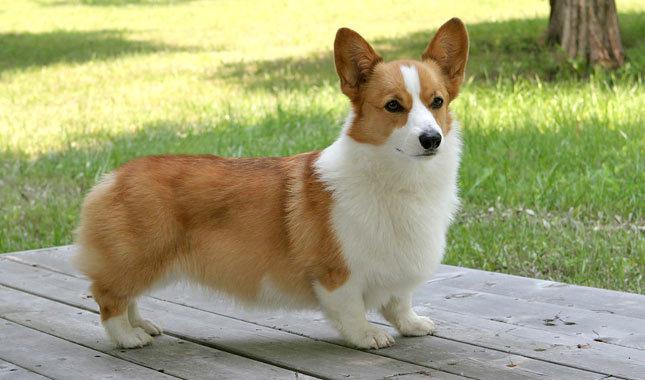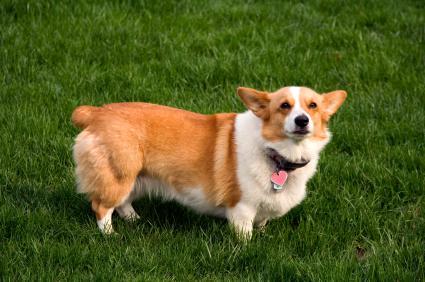The first image is the image on the left, the second image is the image on the right. Evaluate the accuracy of this statement regarding the images: "An image features a multi-colored dog with black markings that create a mask-look.". Is it true? Answer yes or no. No. The first image is the image on the left, the second image is the image on the right. Considering the images on both sides, is "At least one dog has some black fur." valid? Answer yes or no. No. 